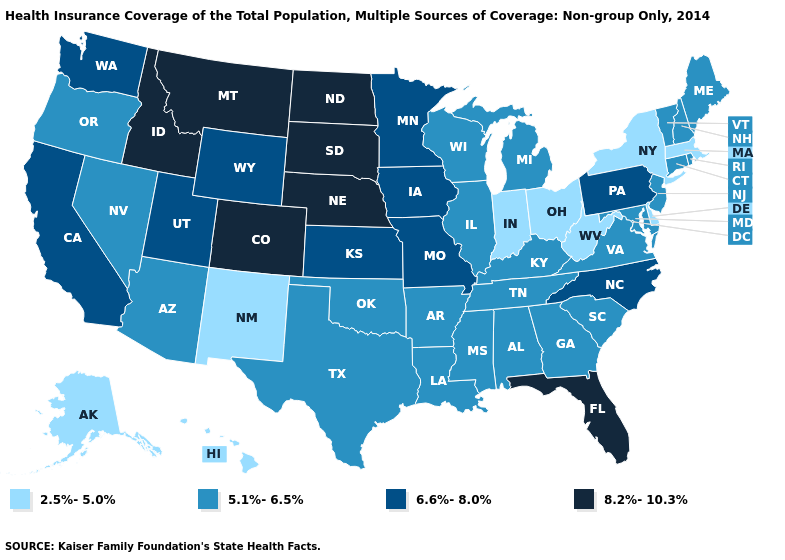How many symbols are there in the legend?
Write a very short answer. 4. Does Colorado have the highest value in the USA?
Quick response, please. Yes. What is the lowest value in the USA?
Short answer required. 2.5%-5.0%. Name the states that have a value in the range 6.6%-8.0%?
Quick response, please. California, Iowa, Kansas, Minnesota, Missouri, North Carolina, Pennsylvania, Utah, Washington, Wyoming. Does Wisconsin have the highest value in the MidWest?
Quick response, please. No. What is the lowest value in the USA?
Keep it brief. 2.5%-5.0%. What is the highest value in the USA?
Answer briefly. 8.2%-10.3%. What is the lowest value in the USA?
Be succinct. 2.5%-5.0%. What is the highest value in the South ?
Concise answer only. 8.2%-10.3%. Which states have the lowest value in the MidWest?
Concise answer only. Indiana, Ohio. What is the lowest value in the West?
Give a very brief answer. 2.5%-5.0%. How many symbols are there in the legend?
Keep it brief. 4. Which states have the highest value in the USA?
Answer briefly. Colorado, Florida, Idaho, Montana, Nebraska, North Dakota, South Dakota. What is the highest value in the South ?
Concise answer only. 8.2%-10.3%. Name the states that have a value in the range 5.1%-6.5%?
Give a very brief answer. Alabama, Arizona, Arkansas, Connecticut, Georgia, Illinois, Kentucky, Louisiana, Maine, Maryland, Michigan, Mississippi, Nevada, New Hampshire, New Jersey, Oklahoma, Oregon, Rhode Island, South Carolina, Tennessee, Texas, Vermont, Virginia, Wisconsin. 